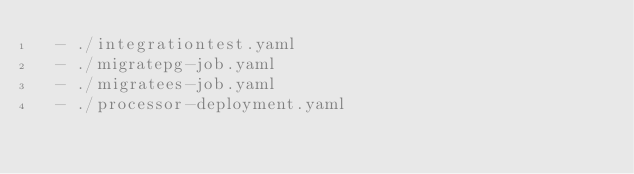Convert code to text. <code><loc_0><loc_0><loc_500><loc_500><_YAML_>  - ./integrationtest.yaml
  - ./migratepg-job.yaml
  - ./migratees-job.yaml
  - ./processor-deployment.yaml
</code> 